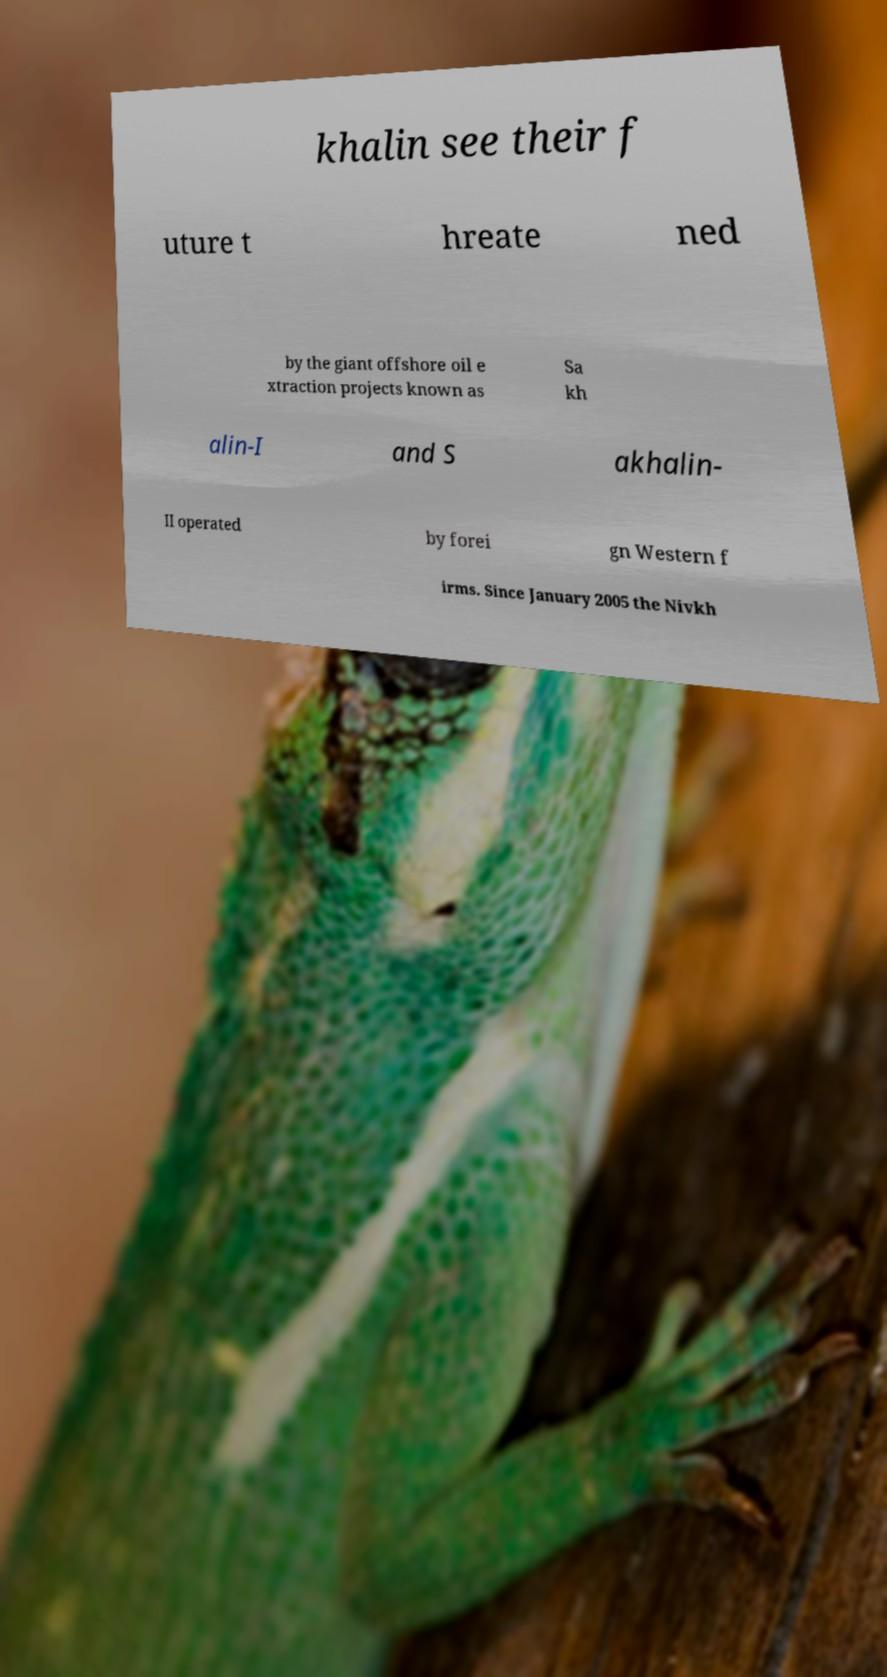Could you extract and type out the text from this image? khalin see their f uture t hreate ned by the giant offshore oil e xtraction projects known as Sa kh alin-I and S akhalin- II operated by forei gn Western f irms. Since January 2005 the Nivkh 